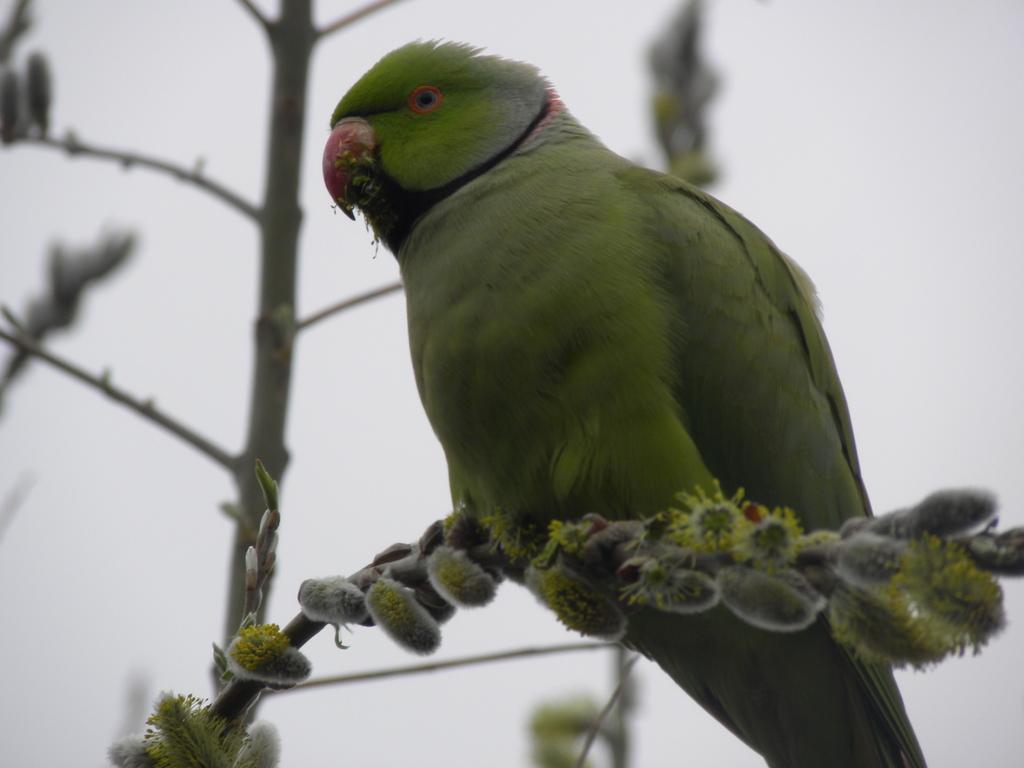Could you give a brief overview of what you see in this image? This picture might be taken from outside of the city. In this image, in the middle, we can see a parrot standing on the tree stem. On the left side, we can see a stem. In the background, we can see a tree and white color. 